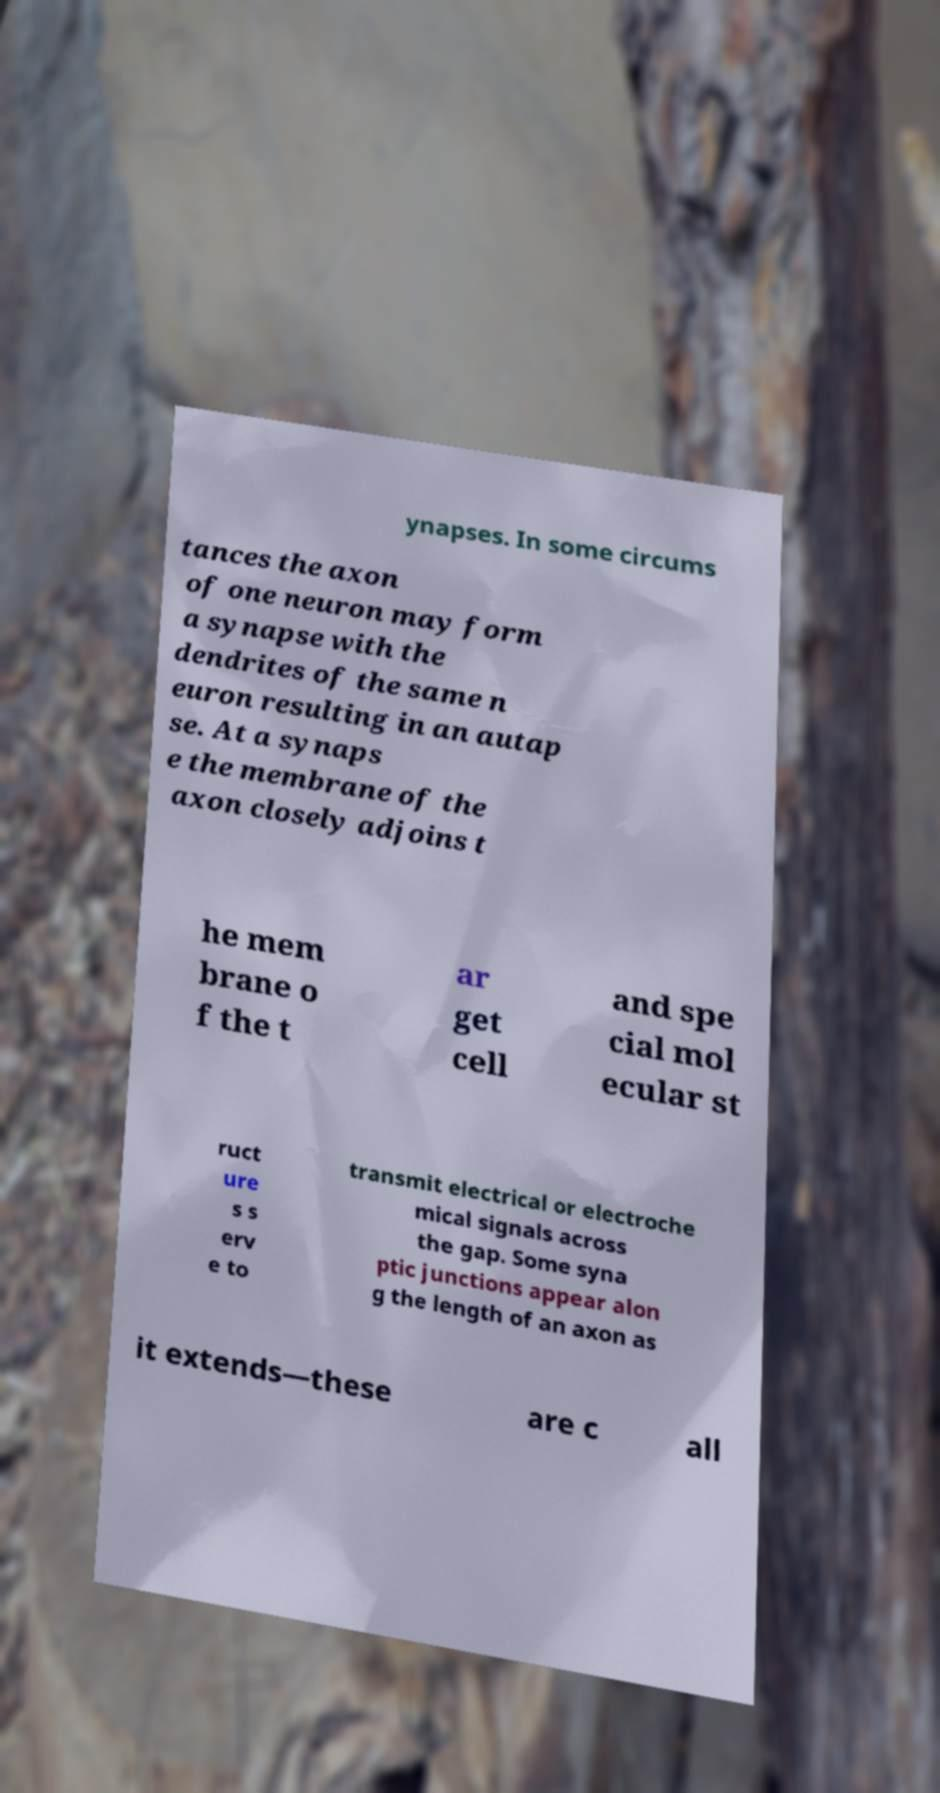Could you extract and type out the text from this image? ynapses. In some circums tances the axon of one neuron may form a synapse with the dendrites of the same n euron resulting in an autap se. At a synaps e the membrane of the axon closely adjoins t he mem brane o f the t ar get cell and spe cial mol ecular st ruct ure s s erv e to transmit electrical or electroche mical signals across the gap. Some syna ptic junctions appear alon g the length of an axon as it extends—these are c all 